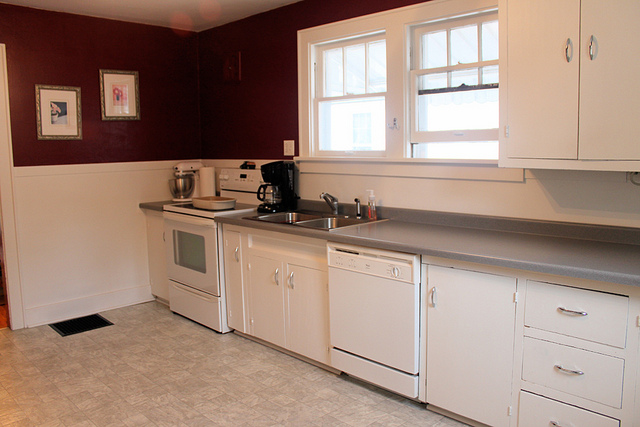If the kitchen could talk, what story would it tell about its daily life? If the kitchen could talk, it would tell stories of hustle and bustle in the mornings—breakfasts being prepared as the sun rises, coffee brewing, and children rushing out for school. It would recount the quieter moments, like mid-morning breaks with tea and a good book. It would share the joy of family dinners, with everyone pitching in to cook, and the warmth of evening conversations over freshly baked cookies. This kitchen is a witness to both the ordinary and extraordinary, filled with love, laughter, and the delicious aromas of home-cooked meals. 